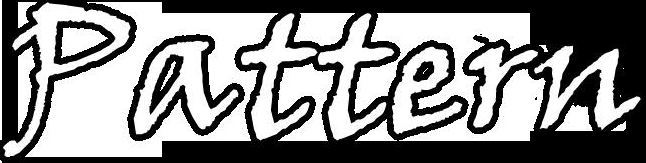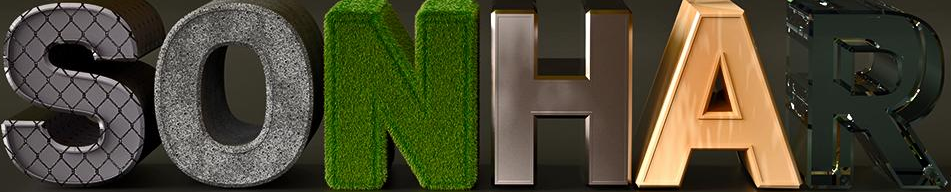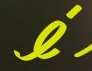What text is displayed in these images sequentially, separated by a semicolon? Pattern; SONHAR; é 